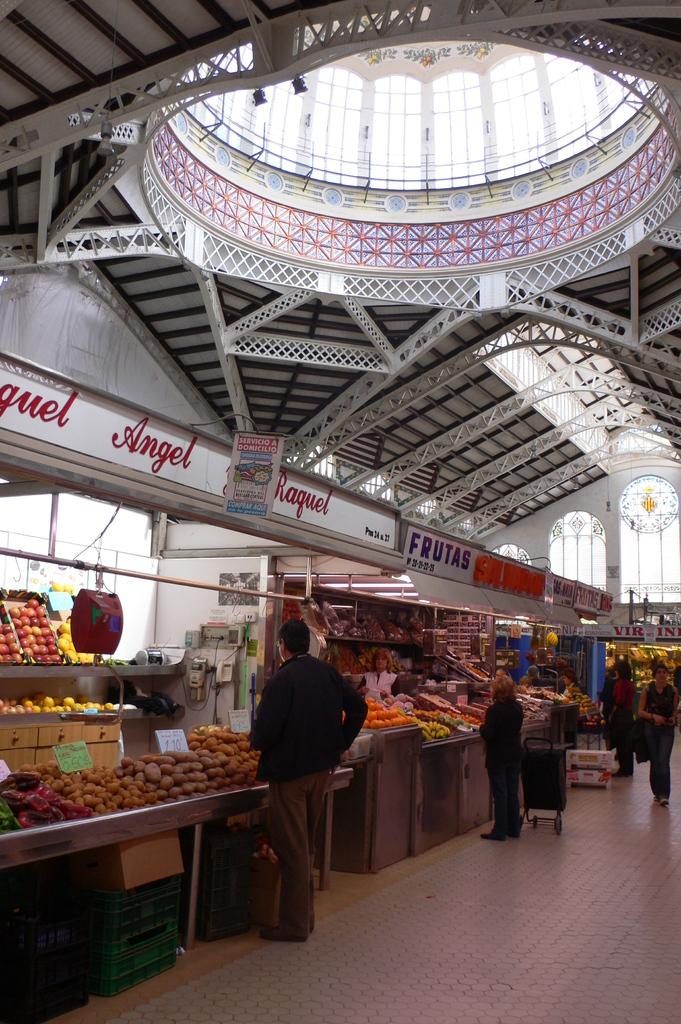What type of location is depicted in the image? There is a market in the picture. What can be found within the market? There are stalls in the market. What type of items can be seen at the stalls? Fruits and food items are visible in the image. Are there any people present in the market? Yes, there are people standing in the market. What color is the plastic floor in the image? There is no plastic floor present in the image. The image does not mention the floor material or color. 